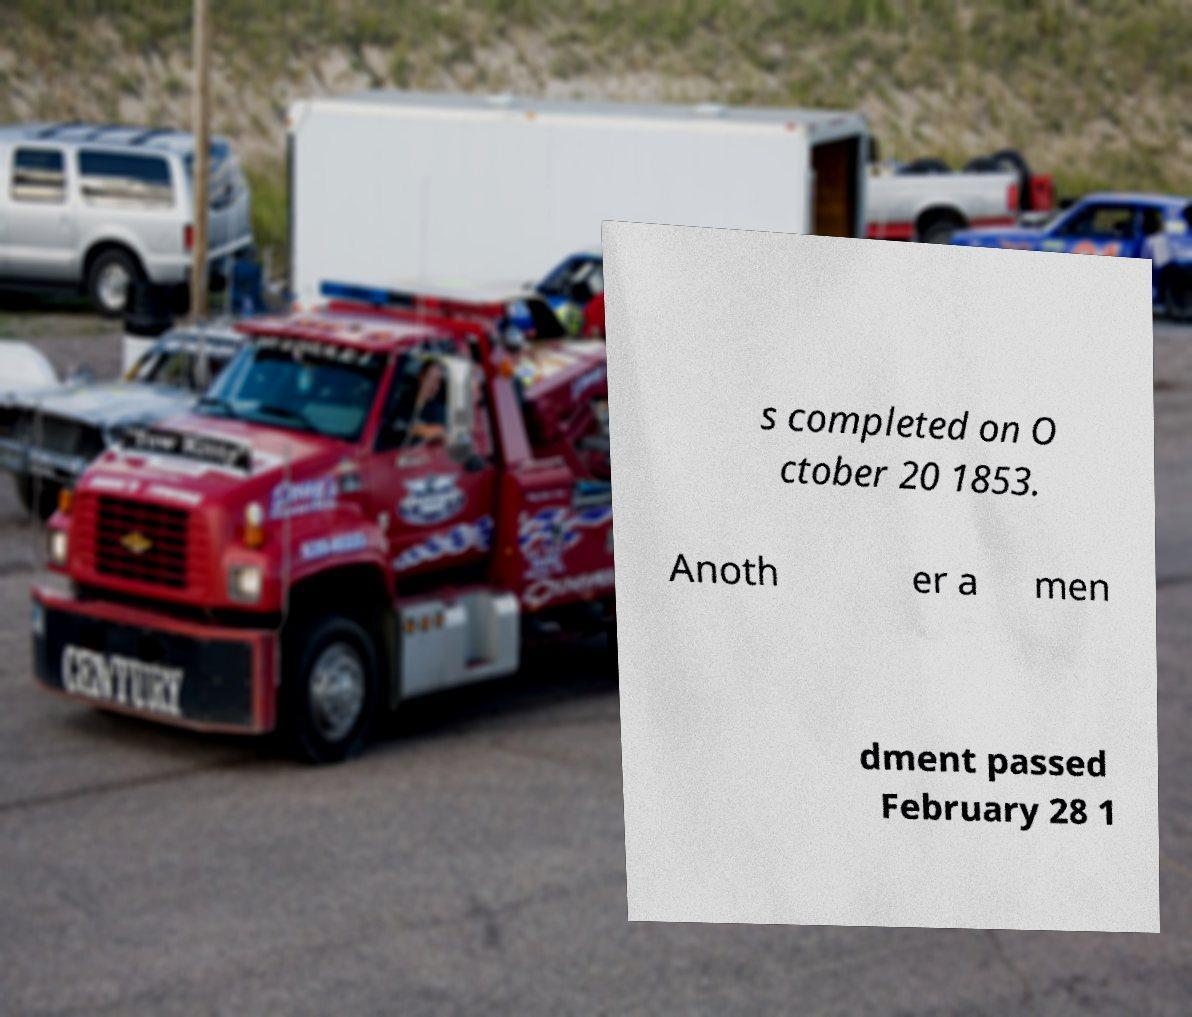For documentation purposes, I need the text within this image transcribed. Could you provide that? s completed on O ctober 20 1853. Anoth er a men dment passed February 28 1 